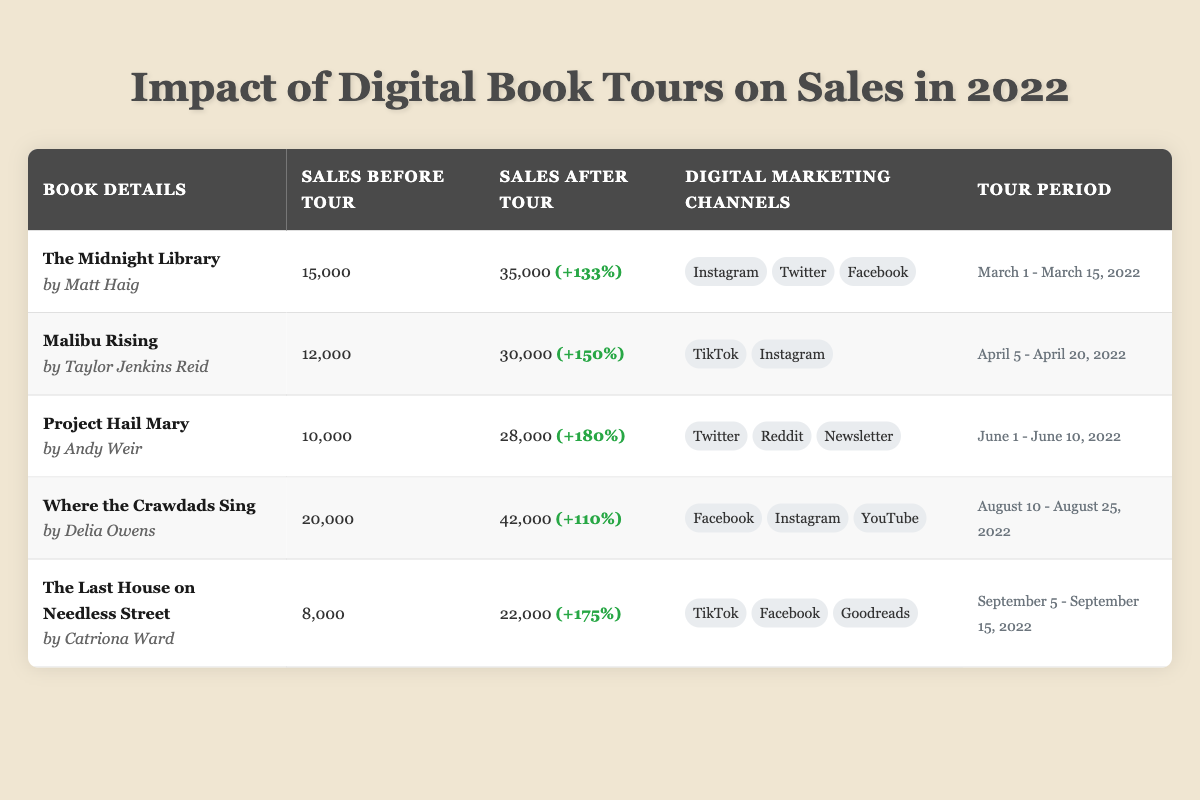What is the title of the book that had the highest sales increase after the digital tour? Looking through the sales increase percentages, "Malibu Rising" had a 150% increase, while "Project Hail Mary" showed 180%. However, "Where the Crawdads Sing" reported a 110% increase. Thus, the highest percentage belongs to "Project Hail Mary".
Answer: Project Hail Mary How many total books listed in the table had sales of 30,000 or more after their tours? By examining the sales after the tour, the books with sales equal to or greater than 30,000 are "The Midnight Library" (35,000), "Malibu Rising" (30,000), "Project Hail Mary" (28,000), and "Where the Crawdads Sing" (42,000). Thus, there are three books.
Answer: Three Did "The Last House on Needless Street" have a lower sales count before or after the tour when compared to "The Midnight Library"? "The Last House on Needless Street" had sales of 8,000 before and 22,000 after the tour. "The Midnight Library" had sales of 15,000 before and 35,000 after the tour. When comparing, "The Last House on Needless Street" had lower sales before and after the tour.
Answer: Yes What was the total sales figure for all books before the digital tours? To find the total sales before the tour, we sum 15,000 (The Midnight Library) + 12,000 (Malibu Rising) + 10,000 (Project Hail Mary) + 20,000 (Where the Crawdads Sing) + 8,000 (The Last House on Needless Street). The calculation thus gives us a total of 65,000.
Answer: 65,000 Which digital marketing channel was used for the highest number of books, and how many? By looking through the marketing channels, "Twitter" and "Instagram" both appear in the marketing plans for two books each, as do "Facebook" and "TikTok". Therefore, the answer must indicate that all these channels were used for the same number of books, which is two.
Answer: Two 